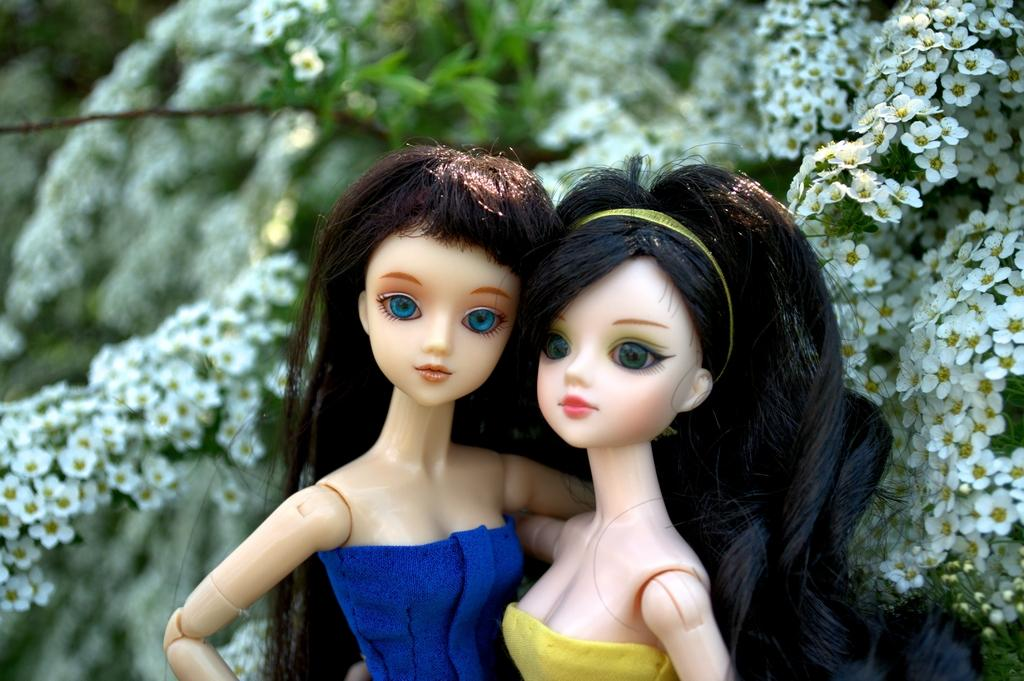How many dolls are in the image? There are two dolls in the image. What colors are the dresses of the dolls? One doll is wearing a yellow dress, and the other doll is wearing a blue dress. What else can be seen in the image besides the dolls? Flowers are present in the image. What riddle does the father tell the dolls in the image? There is no father or riddle present in the image; it only features two dolls and flowers. 